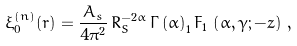<formula> <loc_0><loc_0><loc_500><loc_500>\xi _ { 0 } ^ { ( n ) } ( r ) = \frac { A _ { s } } { 4 \pi ^ { 2 } } \, R _ { S } ^ { - 2 \alpha } \, \Gamma \left ( \alpha \right ) _ { 1 } F _ { 1 } \, \left ( \alpha , \gamma ; - z \right ) \, ,</formula> 